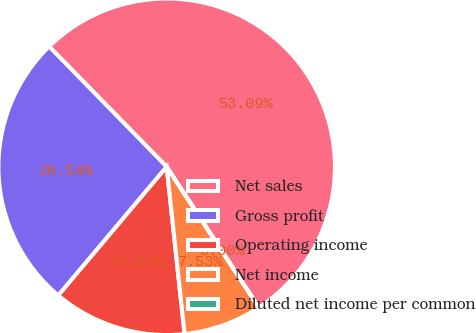Convert chart. <chart><loc_0><loc_0><loc_500><loc_500><pie_chart><fcel>Net sales<fcel>Gross profit<fcel>Operating income<fcel>Net income<fcel>Diluted net income per common<nl><fcel>53.09%<fcel>26.54%<fcel>12.84%<fcel>7.53%<fcel>0.0%<nl></chart> 